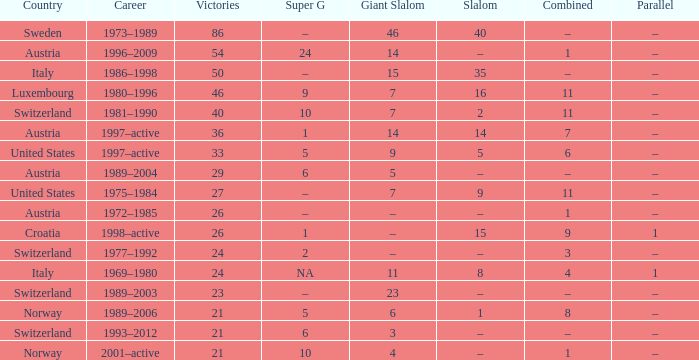What Career has a Parallel of –, a Combined of –, and a Giant Slalom of 5? 1989–2004. 